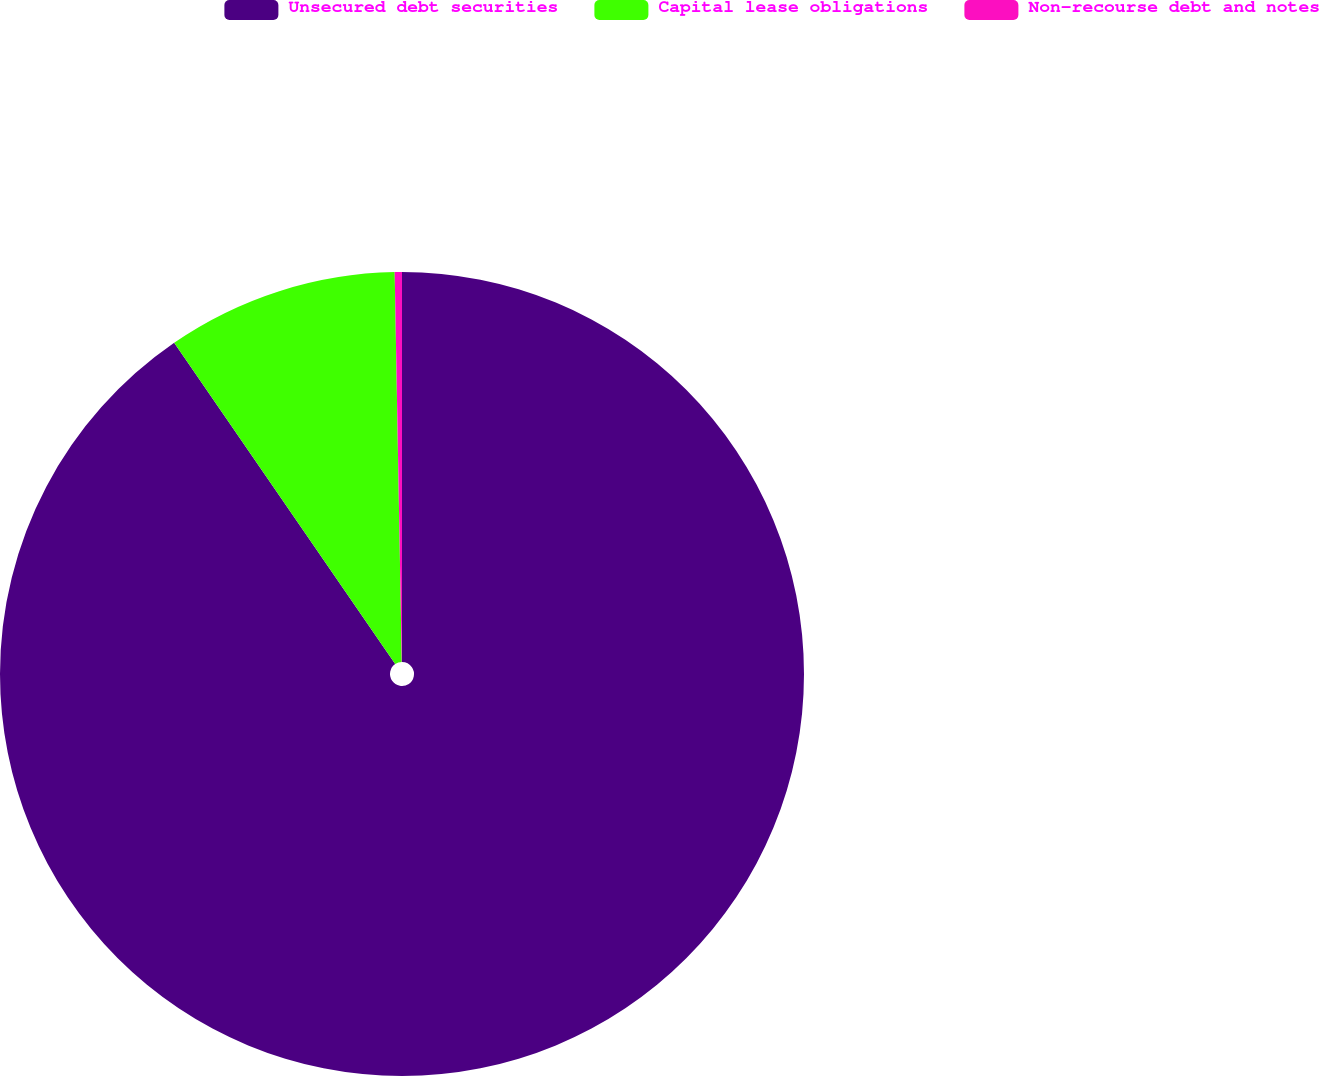Convert chart. <chart><loc_0><loc_0><loc_500><loc_500><pie_chart><fcel>Unsecured debt securities<fcel>Capital lease obligations<fcel>Non-recourse debt and notes<nl><fcel>90.41%<fcel>9.3%<fcel>0.29%<nl></chart> 